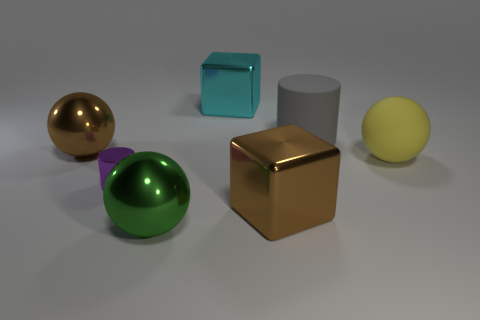Are there any other things that are the same size as the metallic cylinder?
Provide a short and direct response. No. Is there any other thing that is the same color as the rubber ball?
Provide a succinct answer. No. What shape is the big brown shiny object that is to the left of the brown thing to the right of the green sphere?
Provide a short and direct response. Sphere. Are there more large brown spheres than gray spheres?
Your answer should be compact. Yes. What number of big brown shiny things are in front of the big yellow matte thing and on the left side of the purple shiny cylinder?
Give a very brief answer. 0. How many large cyan things are left of the big block that is behind the large yellow sphere?
Offer a terse response. 0. How many things are either big objects that are on the left side of the cyan metallic block or big metal cubes that are behind the big gray cylinder?
Your answer should be very brief. 3. What is the material of the tiny purple thing that is the same shape as the big gray thing?
Provide a short and direct response. Metal. How many objects are either metal objects that are in front of the big gray rubber thing or tiny green spheres?
Your response must be concise. 4. There is a gray thing that is the same material as the yellow object; what is its shape?
Keep it short and to the point. Cylinder. 